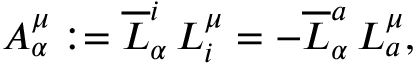Convert formula to latex. <formula><loc_0><loc_0><loc_500><loc_500>A _ { \alpha } ^ { \mu } \colon = \overline { L } _ { \alpha } ^ { i } \, L _ { i } ^ { \mu } = - \overline { L } _ { \alpha } ^ { a } \, L _ { a } ^ { \mu } ,</formula> 